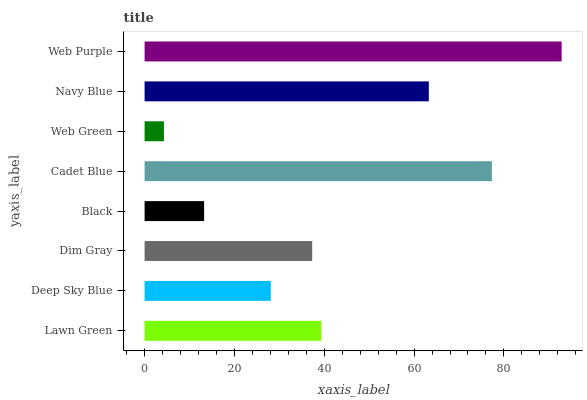Is Web Green the minimum?
Answer yes or no. Yes. Is Web Purple the maximum?
Answer yes or no. Yes. Is Deep Sky Blue the minimum?
Answer yes or no. No. Is Deep Sky Blue the maximum?
Answer yes or no. No. Is Lawn Green greater than Deep Sky Blue?
Answer yes or no. Yes. Is Deep Sky Blue less than Lawn Green?
Answer yes or no. Yes. Is Deep Sky Blue greater than Lawn Green?
Answer yes or no. No. Is Lawn Green less than Deep Sky Blue?
Answer yes or no. No. Is Lawn Green the high median?
Answer yes or no. Yes. Is Dim Gray the low median?
Answer yes or no. Yes. Is Web Purple the high median?
Answer yes or no. No. Is Black the low median?
Answer yes or no. No. 